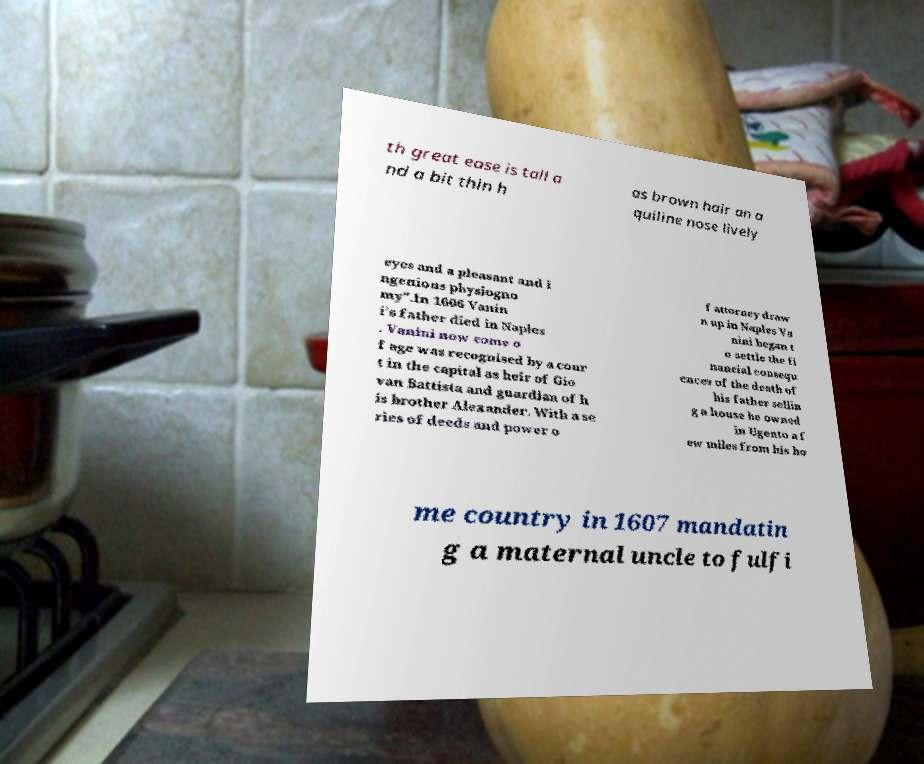Can you accurately transcribe the text from the provided image for me? th great ease is tall a nd a bit thin h as brown hair an a quiline nose lively eyes and a pleasant and i ngenious physiogno my".In 1606 Vanin i's father died in Naples . Vanini now come o f age was recognised by a cour t in the capital as heir of Gio van Battista and guardian of h is brother Alexander. With a se ries of deeds and power o f attorney draw n up in Naples Va nini began t o settle the fi nancial consequ ences of the death of his father sellin g a house he owned in Ugento a f ew miles from his ho me country in 1607 mandatin g a maternal uncle to fulfi 